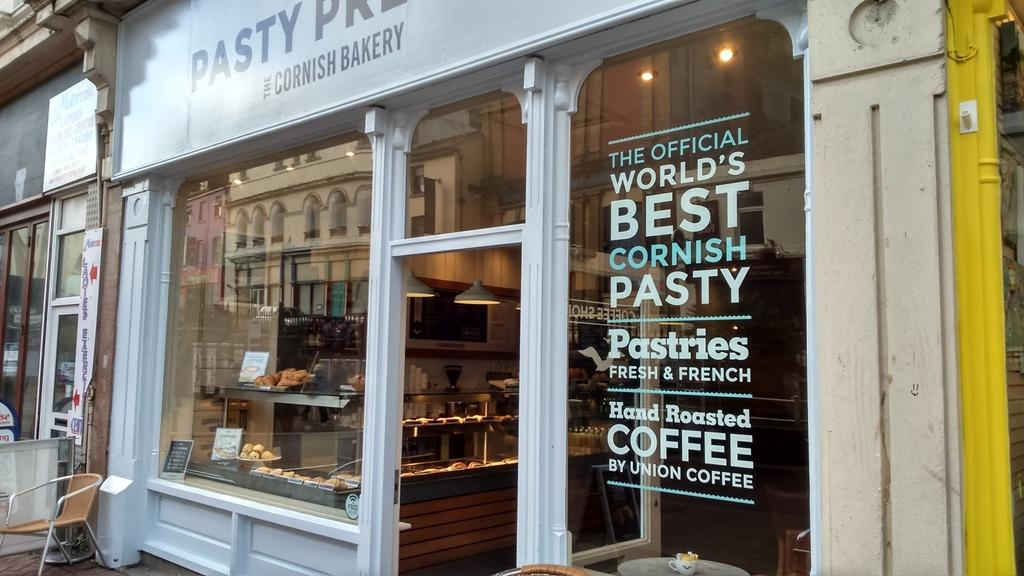<image>
Render a clear and concise summary of the photo. the front of a pasty shop with a window sticker stating they're the world's best cornish pasty 